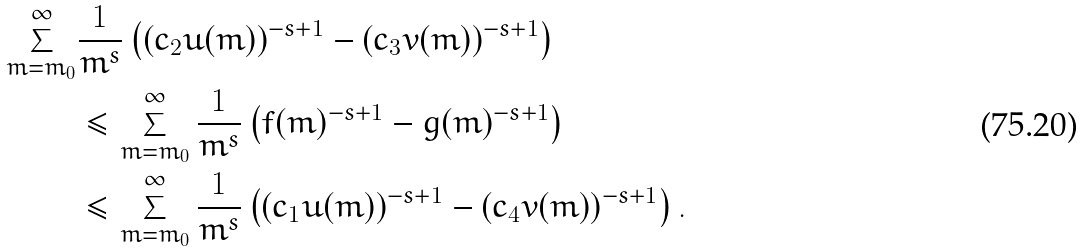Convert formula to latex. <formula><loc_0><loc_0><loc_500><loc_500>\sum _ { m = m _ { 0 } } ^ { \infty } & \frac { 1 } { m ^ { s } } \left ( ( c _ { 2 } u ( m ) ) ^ { - s + 1 } - ( c _ { 3 } v ( m ) ) ^ { - s + 1 } \right ) \\ & \leq \sum _ { m = m _ { 0 } } ^ { \infty } \frac { 1 } { m ^ { s } } \left ( f ( m ) ^ { - s + 1 } - g ( m ) ^ { - s + 1 } \right ) \\ & \leq \sum _ { m = m _ { 0 } } ^ { \infty } \frac { 1 } { m ^ { s } } \left ( ( c _ { 1 } u ( m ) ) ^ { - s + 1 } - ( c _ { 4 } v ( m ) ) ^ { - s + 1 } \right ) .</formula> 